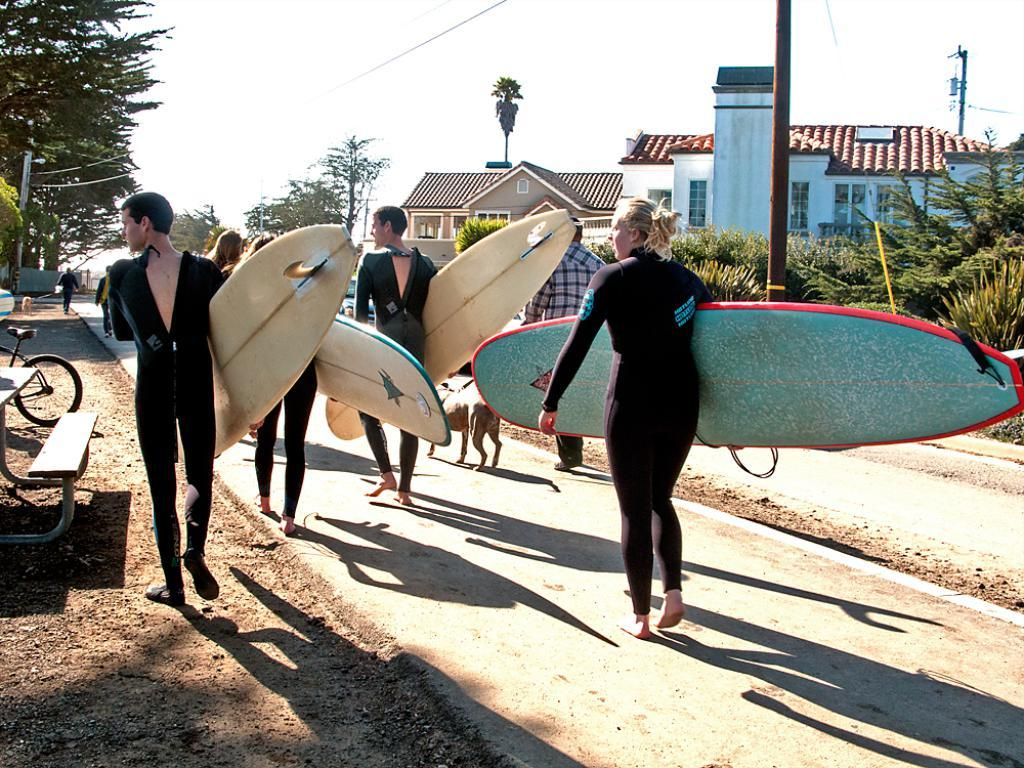What are the persons in the center of the image doing? The persons in the center of the image are holding surfboards. What can be seen in the background of the image? In the background of the image, there are clouds in the sky, trees, a building, a roof, a window, and a road. Can you describe the sky in the image? The sky in the image has clouds. What type of mint can be seen growing near the window in the image? There is no mint visible in the image; the focus is on the persons holding surfboards and the background elements. 